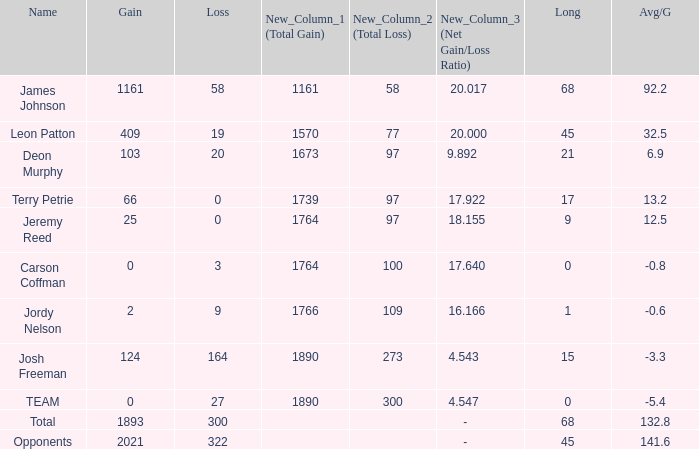How many losses did leon patton have with the longest gain higher than 45? 0.0. 